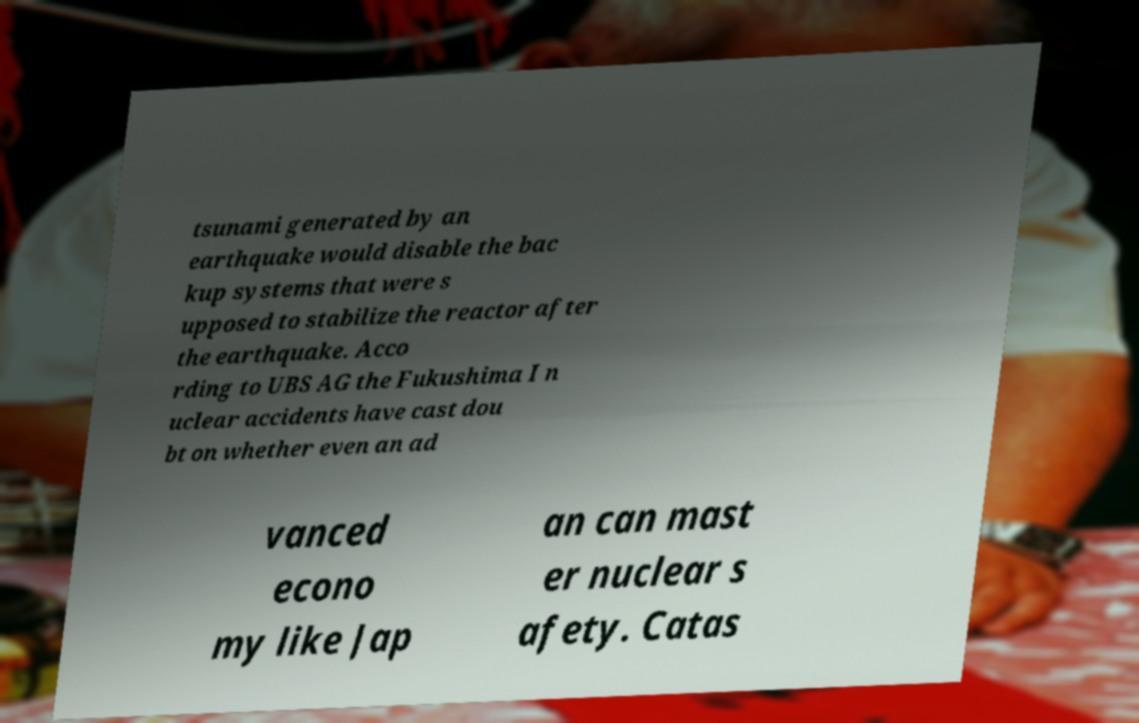Can you accurately transcribe the text from the provided image for me? tsunami generated by an earthquake would disable the bac kup systems that were s upposed to stabilize the reactor after the earthquake. Acco rding to UBS AG the Fukushima I n uclear accidents have cast dou bt on whether even an ad vanced econo my like Jap an can mast er nuclear s afety. Catas 